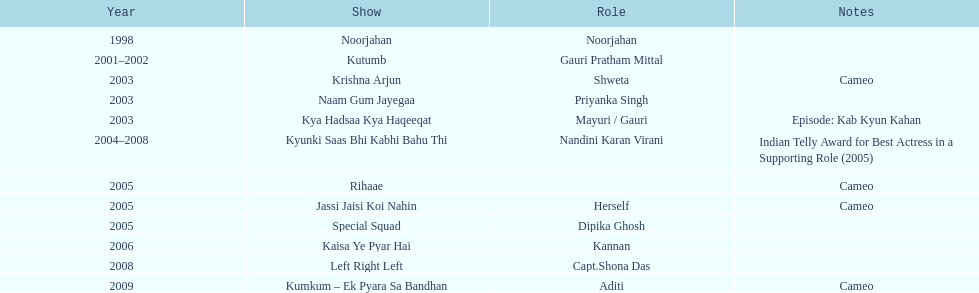What is the initial television series featuring gauri tejwani? Noorjahan. 